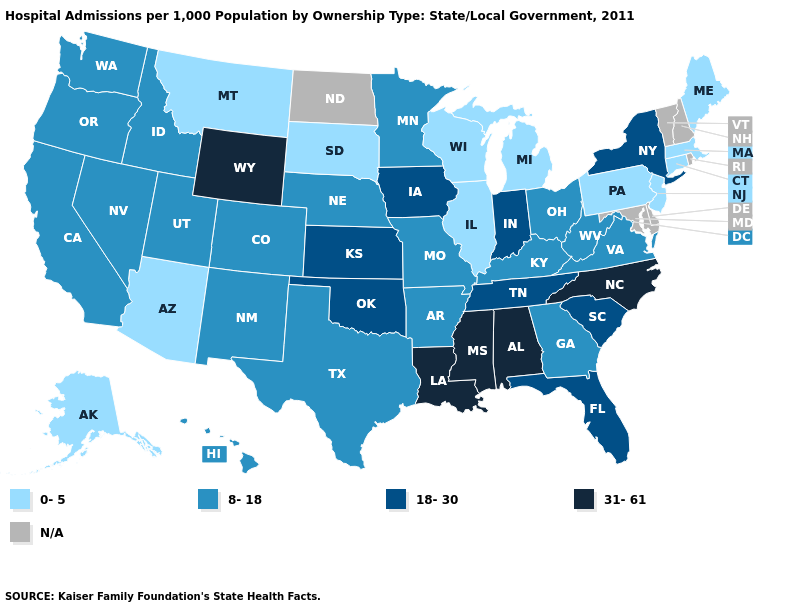What is the value of Wyoming?
Quick response, please. 31-61. Among the states that border Louisiana , does Arkansas have the highest value?
Answer briefly. No. What is the highest value in the West ?
Concise answer only. 31-61. What is the lowest value in states that border Michigan?
Write a very short answer. 0-5. What is the value of Georgia?
Answer briefly. 8-18. Name the states that have a value in the range 18-30?
Quick response, please. Florida, Indiana, Iowa, Kansas, New York, Oklahoma, South Carolina, Tennessee. What is the lowest value in states that border North Dakota?
Give a very brief answer. 0-5. Does Pennsylvania have the lowest value in the USA?
Concise answer only. Yes. What is the highest value in the Northeast ?
Quick response, please. 18-30. Does the first symbol in the legend represent the smallest category?
Answer briefly. Yes. Among the states that border North Carolina , which have the lowest value?
Short answer required. Georgia, Virginia. Does the map have missing data?
Short answer required. Yes. Name the states that have a value in the range N/A?
Give a very brief answer. Delaware, Maryland, New Hampshire, North Dakota, Rhode Island, Vermont. 